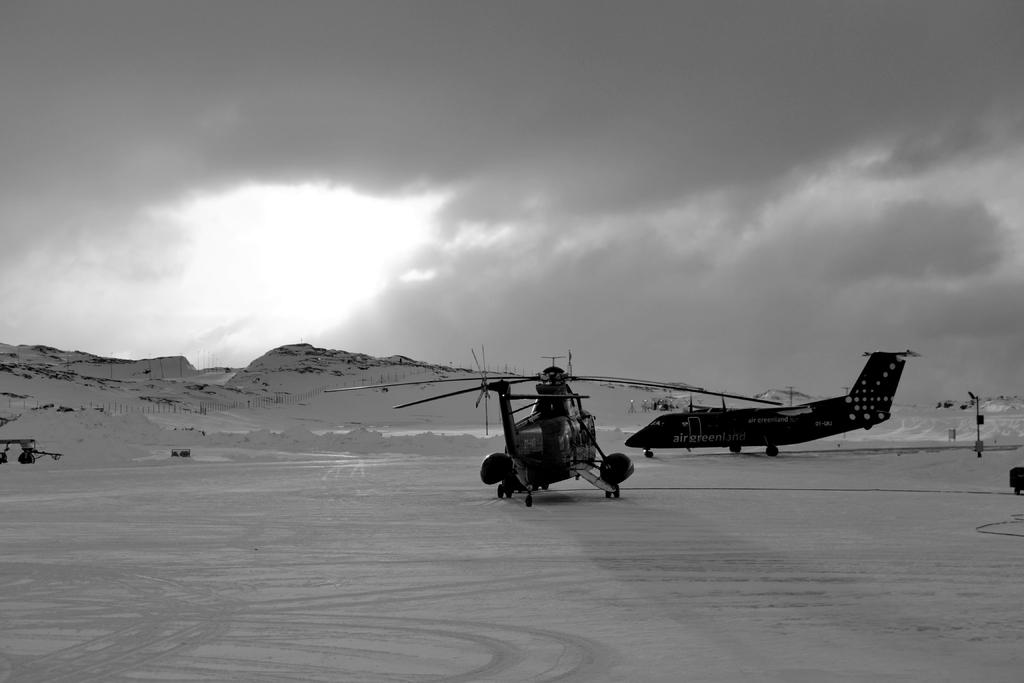What are the two types of aircraft in the image? There is a plane and a helicopter in the image. Where are the plane and helicopter located? Both the plane and helicopter are on the land. What can be seen in the background of the image? There are mountains covered with snow in the background of the image. How would you describe the sky in the image? The sky is covered with clouds. What type of berry is growing on the wing of the helicopter in the image? There are no berries present on the helicopter or anywhere else in the image. 